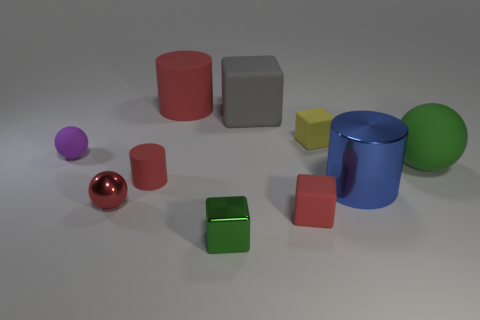There is a tiny cylinder; does it have the same color as the large cylinder that is left of the small red block?
Provide a short and direct response. Yes. There is a cylinder behind the matte sphere to the right of the purple matte ball to the left of the large gray rubber object; how big is it?
Offer a very short reply. Large. How many rubber blocks have the same color as the tiny metal block?
Your response must be concise. 0. How many objects are either large green spheres or red cylinders in front of the large green thing?
Your answer should be compact. 2. The metallic ball has what color?
Your answer should be compact. Red. What is the color of the small rubber cube that is on the left side of the yellow matte object?
Your answer should be compact. Red. There is a red rubber cylinder that is in front of the small purple matte ball; what number of blocks are in front of it?
Your answer should be very brief. 2. There is a blue shiny cylinder; does it have the same size as the block that is in front of the red rubber cube?
Offer a very short reply. No. Are there any gray blocks that have the same size as the blue cylinder?
Give a very brief answer. Yes. How many objects are either purple matte objects or tiny balls?
Your response must be concise. 2. 